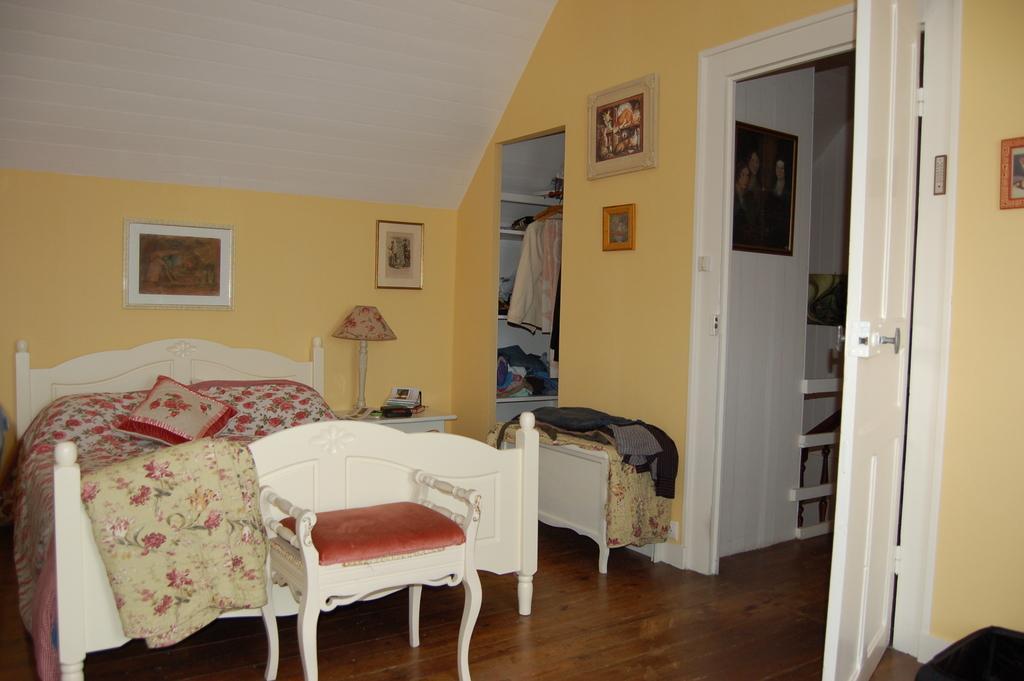Describe this image in one or two sentences. In this image there is a bed, there are blankets on the bed, there is a pillow, there are tables, there are objects on the tables, there is a wooden floor, there is an object towards the bottom of the image, there is a door, there is the wall, there are photo frames on the wall, there are shelves, there are objects on the shelves, there is roof towards the top of the image. 